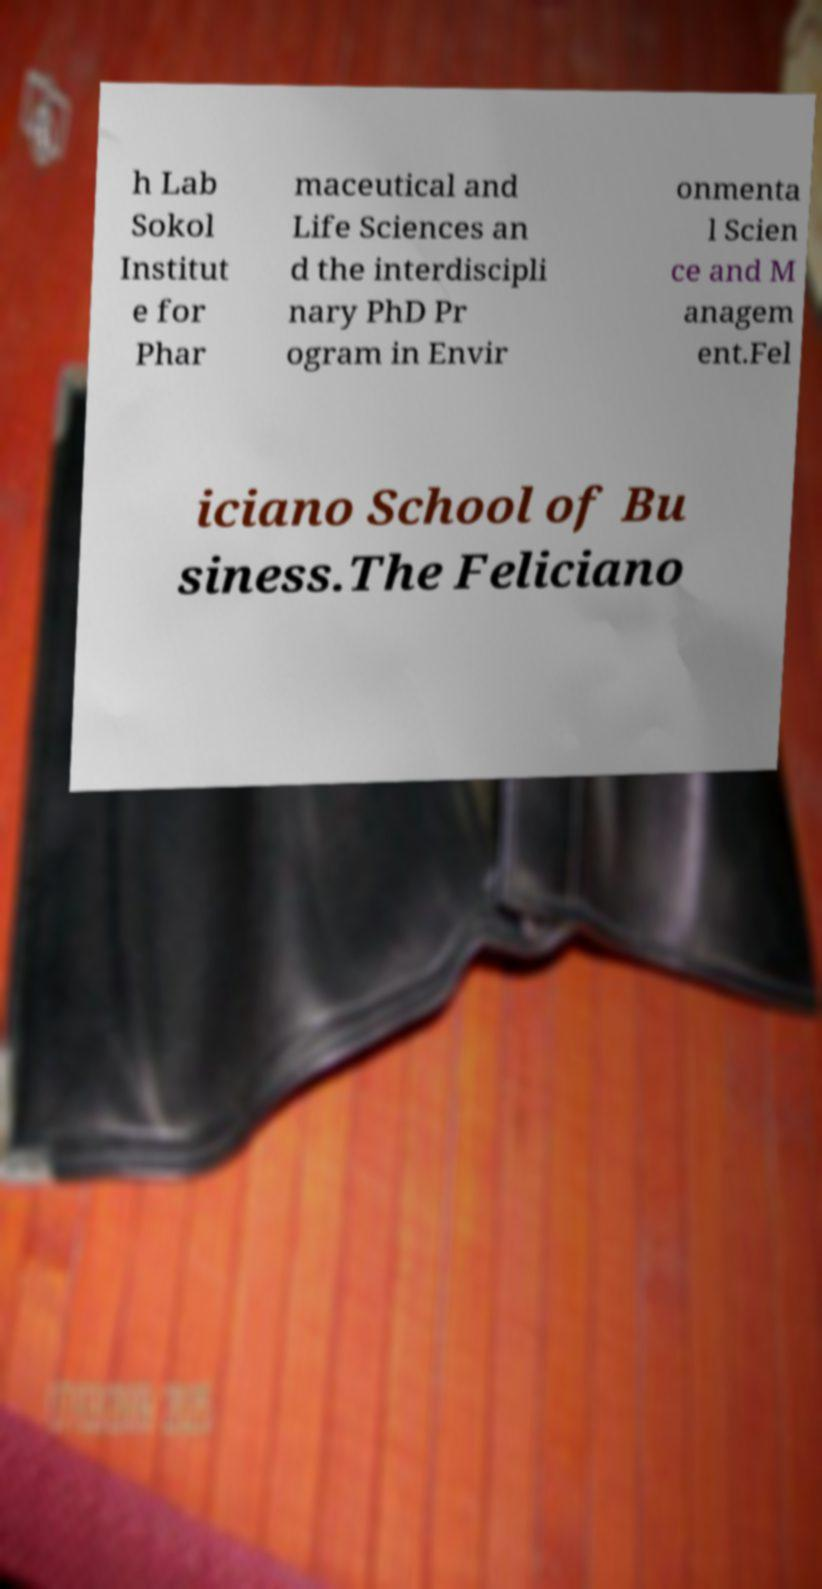For documentation purposes, I need the text within this image transcribed. Could you provide that? h Lab Sokol Institut e for Phar maceutical and Life Sciences an d the interdiscipli nary PhD Pr ogram in Envir onmenta l Scien ce and M anagem ent.Fel iciano School of Bu siness.The Feliciano 